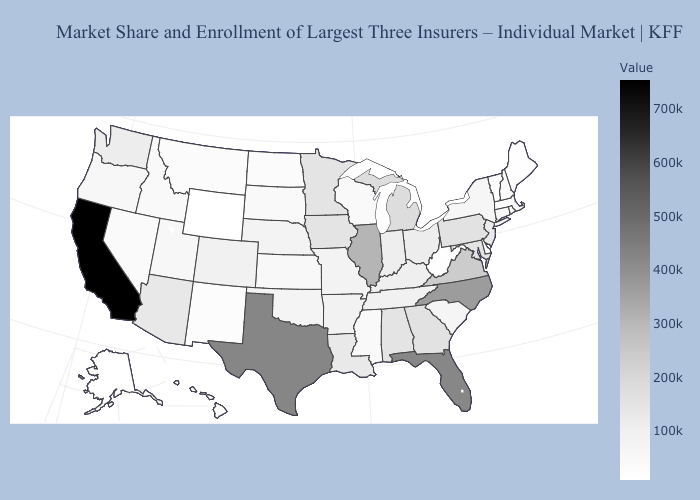Among the states that border Illinois , which have the lowest value?
Short answer required. Wisconsin. Does Idaho have the lowest value in the USA?
Give a very brief answer. No. Is the legend a continuous bar?
Quick response, please. Yes. Among the states that border Missouri , does Kansas have the lowest value?
Concise answer only. Yes. 